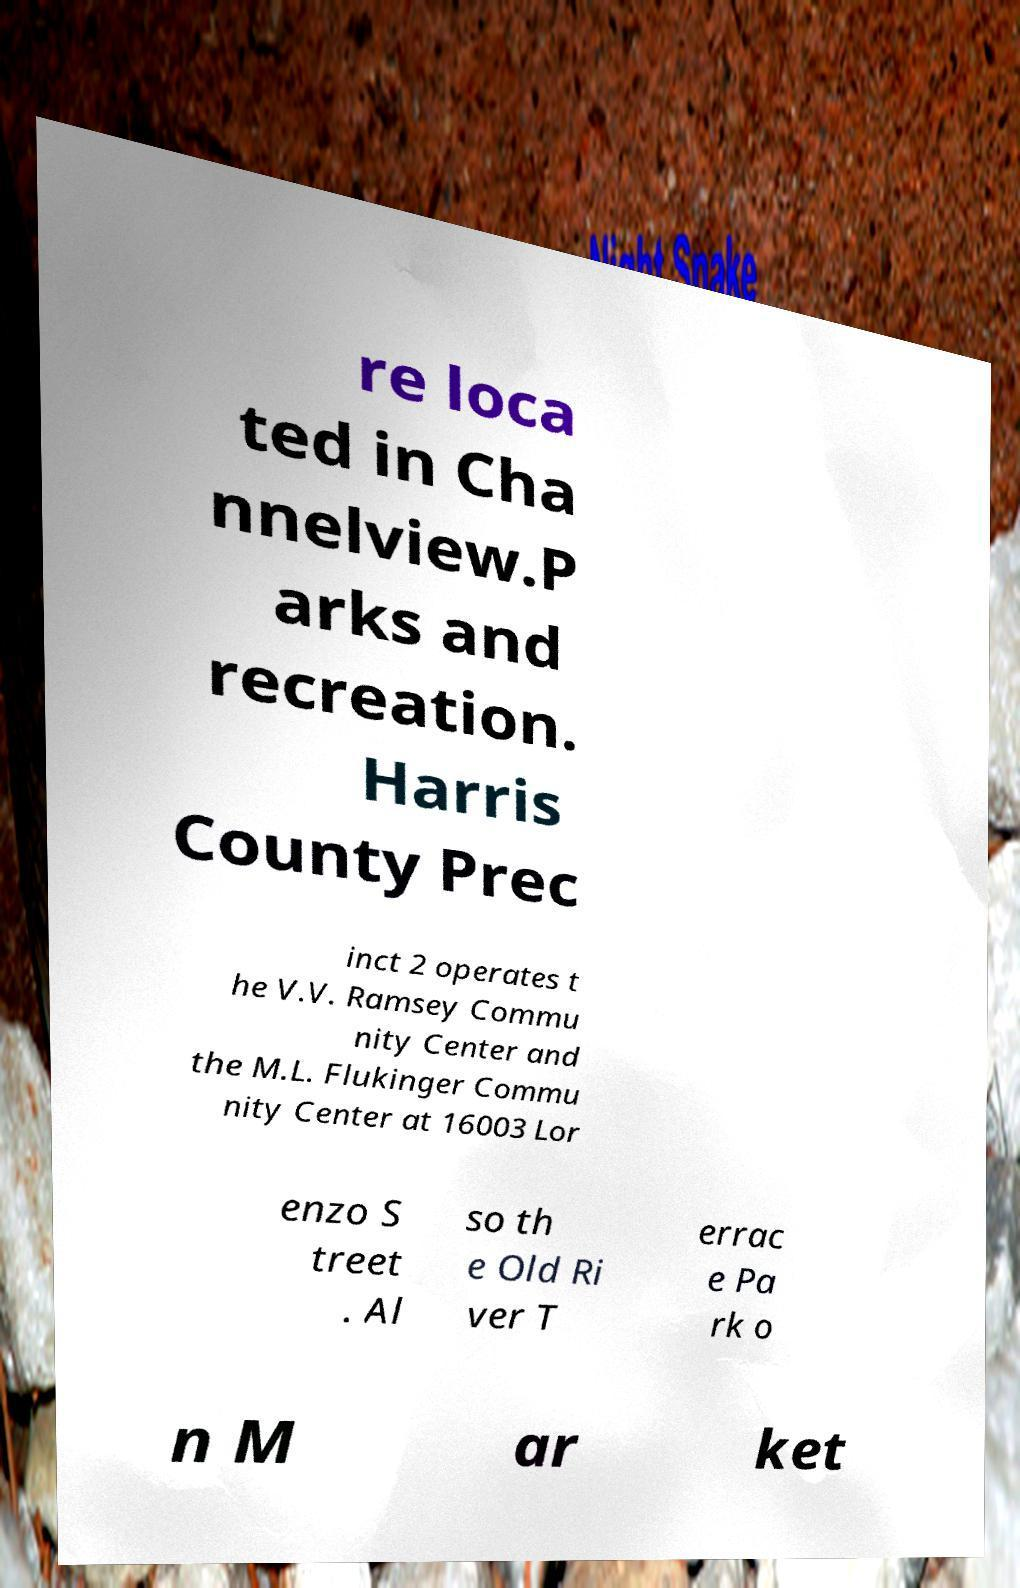What messages or text are displayed in this image? I need them in a readable, typed format. re loca ted in Cha nnelview.P arks and recreation. Harris County Prec inct 2 operates t he V.V. Ramsey Commu nity Center and the M.L. Flukinger Commu nity Center at 16003 Lor enzo S treet . Al so th e Old Ri ver T errac e Pa rk o n M ar ket 